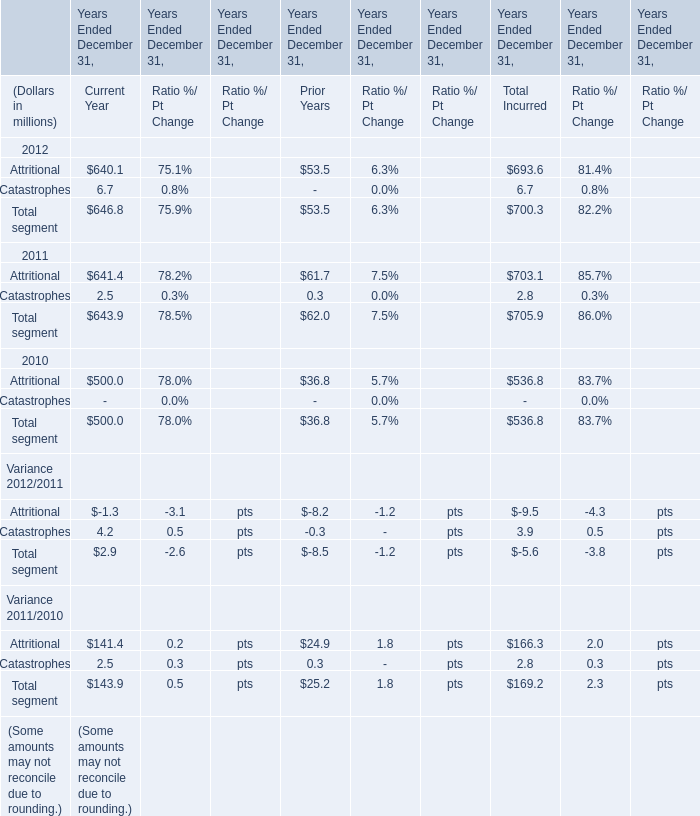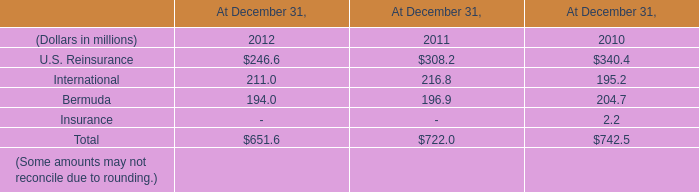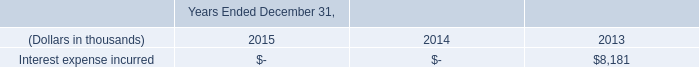What was the total amount of Attritional excluding those Attritional greater than 700 in 2012 for Current Year Prior Years 
Computations: (640.1 + 53.5)
Answer: 693.6. 